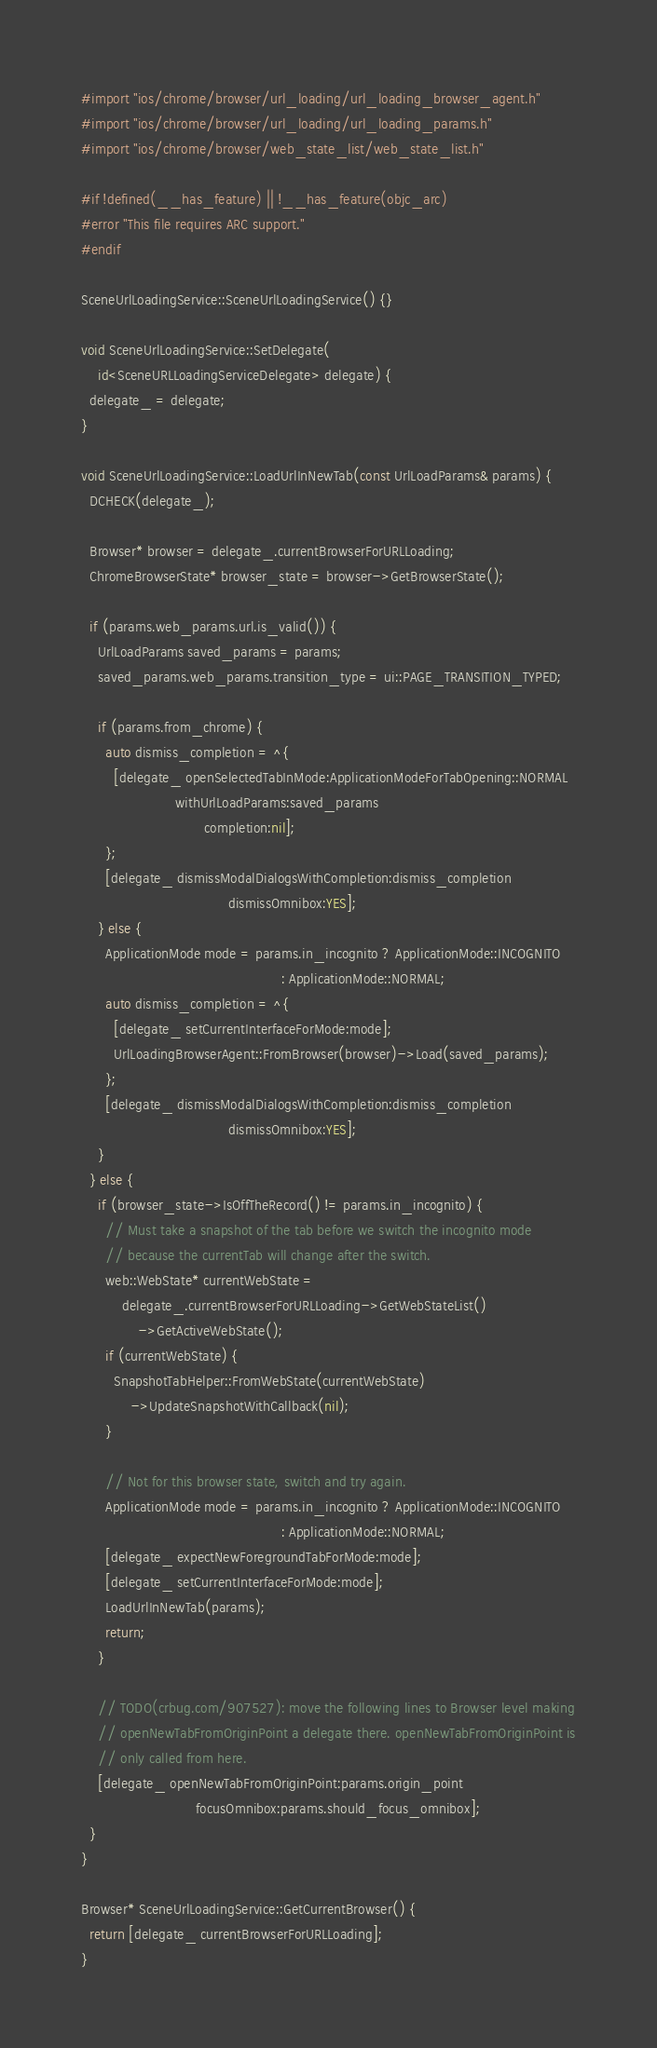Convert code to text. <code><loc_0><loc_0><loc_500><loc_500><_ObjectiveC_>#import "ios/chrome/browser/url_loading/url_loading_browser_agent.h"
#import "ios/chrome/browser/url_loading/url_loading_params.h"
#import "ios/chrome/browser/web_state_list/web_state_list.h"

#if !defined(__has_feature) || !__has_feature(objc_arc)
#error "This file requires ARC support."
#endif

SceneUrlLoadingService::SceneUrlLoadingService() {}

void SceneUrlLoadingService::SetDelegate(
    id<SceneURLLoadingServiceDelegate> delegate) {
  delegate_ = delegate;
}

void SceneUrlLoadingService::LoadUrlInNewTab(const UrlLoadParams& params) {
  DCHECK(delegate_);

  Browser* browser = delegate_.currentBrowserForURLLoading;
  ChromeBrowserState* browser_state = browser->GetBrowserState();

  if (params.web_params.url.is_valid()) {
    UrlLoadParams saved_params = params;
    saved_params.web_params.transition_type = ui::PAGE_TRANSITION_TYPED;

    if (params.from_chrome) {
      auto dismiss_completion = ^{
        [delegate_ openSelectedTabInMode:ApplicationModeForTabOpening::NORMAL
                       withUrlLoadParams:saved_params
                              completion:nil];
      };
      [delegate_ dismissModalDialogsWithCompletion:dismiss_completion
                                    dismissOmnibox:YES];
    } else {
      ApplicationMode mode = params.in_incognito ? ApplicationMode::INCOGNITO
                                                 : ApplicationMode::NORMAL;
      auto dismiss_completion = ^{
        [delegate_ setCurrentInterfaceForMode:mode];
        UrlLoadingBrowserAgent::FromBrowser(browser)->Load(saved_params);
      };
      [delegate_ dismissModalDialogsWithCompletion:dismiss_completion
                                    dismissOmnibox:YES];
    }
  } else {
    if (browser_state->IsOffTheRecord() != params.in_incognito) {
      // Must take a snapshot of the tab before we switch the incognito mode
      // because the currentTab will change after the switch.
      web::WebState* currentWebState =
          delegate_.currentBrowserForURLLoading->GetWebStateList()
              ->GetActiveWebState();
      if (currentWebState) {
        SnapshotTabHelper::FromWebState(currentWebState)
            ->UpdateSnapshotWithCallback(nil);
      }

      // Not for this browser state, switch and try again.
      ApplicationMode mode = params.in_incognito ? ApplicationMode::INCOGNITO
                                                 : ApplicationMode::NORMAL;
      [delegate_ expectNewForegroundTabForMode:mode];
      [delegate_ setCurrentInterfaceForMode:mode];
      LoadUrlInNewTab(params);
      return;
    }

    // TODO(crbug.com/907527): move the following lines to Browser level making
    // openNewTabFromOriginPoint a delegate there. openNewTabFromOriginPoint is
    // only called from here.
    [delegate_ openNewTabFromOriginPoint:params.origin_point
                            focusOmnibox:params.should_focus_omnibox];
  }
}

Browser* SceneUrlLoadingService::GetCurrentBrowser() {
  return [delegate_ currentBrowserForURLLoading];
}
</code> 